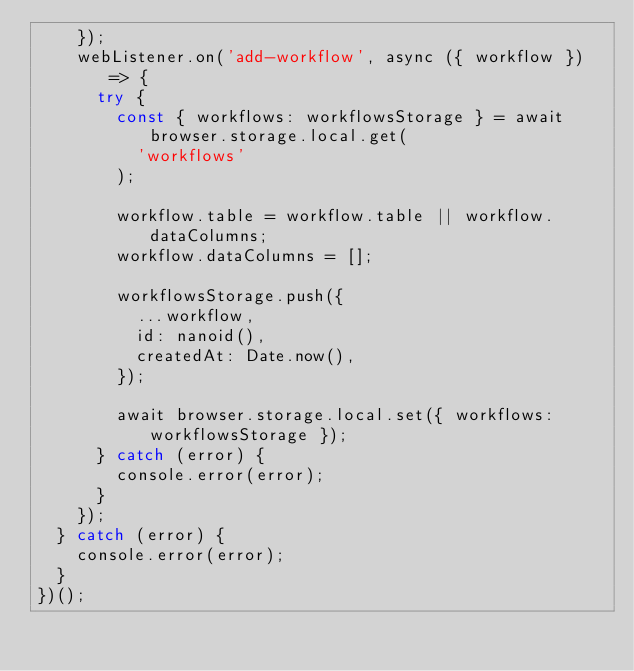<code> <loc_0><loc_0><loc_500><loc_500><_JavaScript_>    });
    webListener.on('add-workflow', async ({ workflow }) => {
      try {
        const { workflows: workflowsStorage } = await browser.storage.local.get(
          'workflows'
        );

        workflow.table = workflow.table || workflow.dataColumns;
        workflow.dataColumns = [];

        workflowsStorage.push({
          ...workflow,
          id: nanoid(),
          createdAt: Date.now(),
        });

        await browser.storage.local.set({ workflows: workflowsStorage });
      } catch (error) {
        console.error(error);
      }
    });
  } catch (error) {
    console.error(error);
  }
})();
</code> 